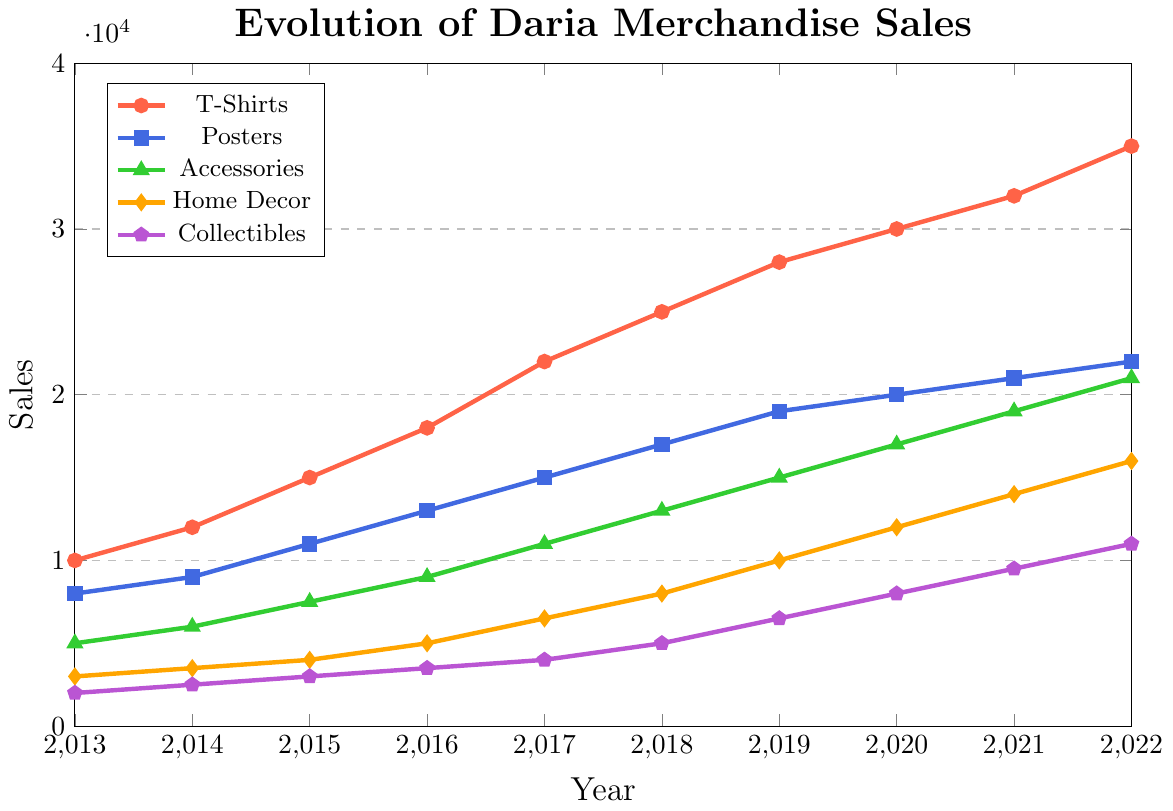What's the overall trend in T-Shirts sales from 2013 to 2022? The T-Shirts sales have been increasing consistently every year from 2013, where the sales were 10,000, to 2022, where they reached 35,000.
Answer: Increasing In which year did Posters sales surpass 15,000? To find when Posters sales exceeded 15,000, we examine the data points: Posters sales reached 15,000 in 2017.
Answer: 2017 What's the difference in Home Decor sales between 2019 and 2022? Home Decor sales in 2019 were 10,000 and in 2022 they were 16,000. The difference is 16,000 - 10,000.
Answer: 6,000 Which product category had the lowest sales in 2013? Looking at the initial values for each category in 2013, Collectibles had the lowest sales at 2,000.
Answer: Collectibles Calculate the average sales of Accessories from 2013 to 2022. The sales figures for Accessories from 2013 to 2022 are: 5,000, 6,000, 7,500, 9,000, 11,000, 13,000, 15,000, 17,000, 19,000, 21,000. The sum is 123,500, and the average is 123,500/10.
Answer: 12,350 Which product category saw the highest growth rate from 2013 to 2022? Growth rate is calculated as (final value - initial value)/initial value. Calculating this for each category:
- T-Shirts: (35,000 - 10,000)/10,000 = 2.5
- Posters: (22,000 - 8,000)/8,000 = 1.75
- Accessories: (21,000 - 5,000)/5,000 = 3.2
- Home Decor: (16,000 - 3,000)/3,000 = 4.33
- Collectibles: (11,000 - 2,000)/2,000 = 4.5
Collectibles have the highest growth rate at 4.5.
Answer: Collectibles How did the sales for Accessories change between 2017 and 2019? Accessories sales in 2017 were 11,000 and in 2019 they were 15,000. The change is 15,000 - 11,000.
Answer: Increased by 4,000 By how much did T-Shirts sales exceed Home Decor sales in 2022? T-Shirts sales in 2022 were 35,000 and Home Decor sales were 16,000. The difference is 35,000 - 16,000.
Answer: 19,000 What are the key differences in the visual colors representing each category? Each category is represented by a distinct color: T-Shirts in red, Posters in blue, Accessories in green, Home Decor in orange, and Collectibles in purple. This helps distinguish the categories visually on the chart.
Answer: T-Shirts: red, Posters: blue, Accessories: green, Home Decor: orange, Collectibles: purple 